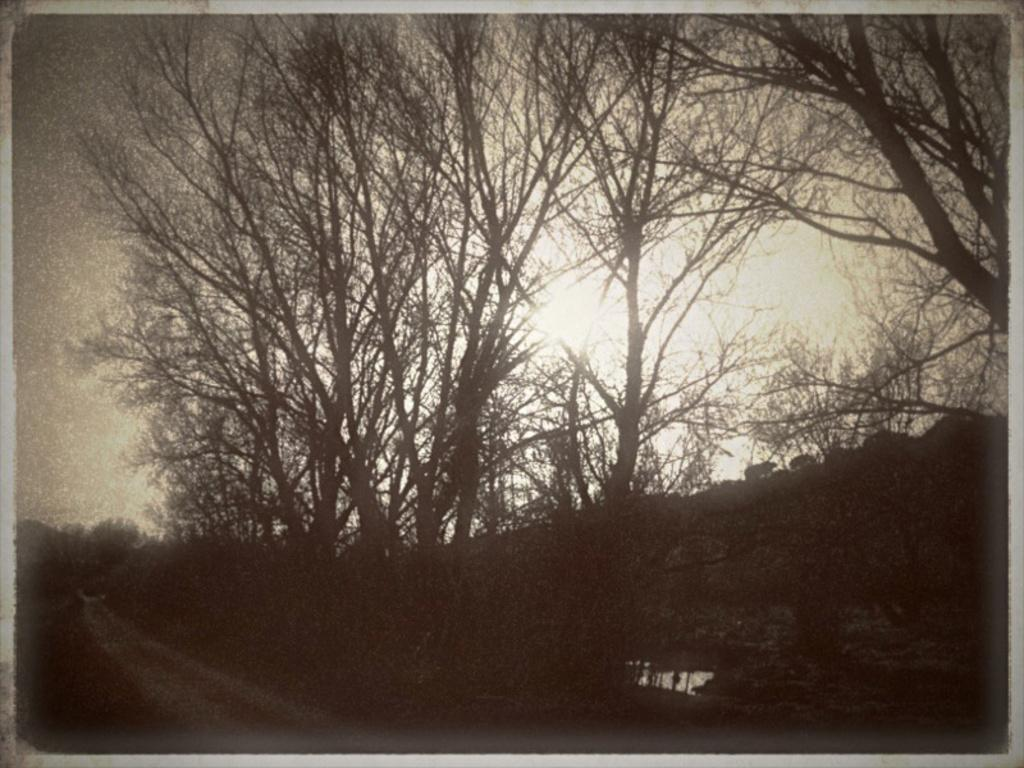What type of picture is in the image? The image contains a black and white picture. What can be seen in the picture? There is a group of trees and water visible in the picture. Are there any living creatures in the picture? Yes, there are animals on the ground in the picture. What part of the natural environment is visible in the picture? The sky is visible at the top of the image. What type of event is taking place in the picture? There is no event visible in the picture; it is a static image of a group of trees, water, animals, and the sky. 